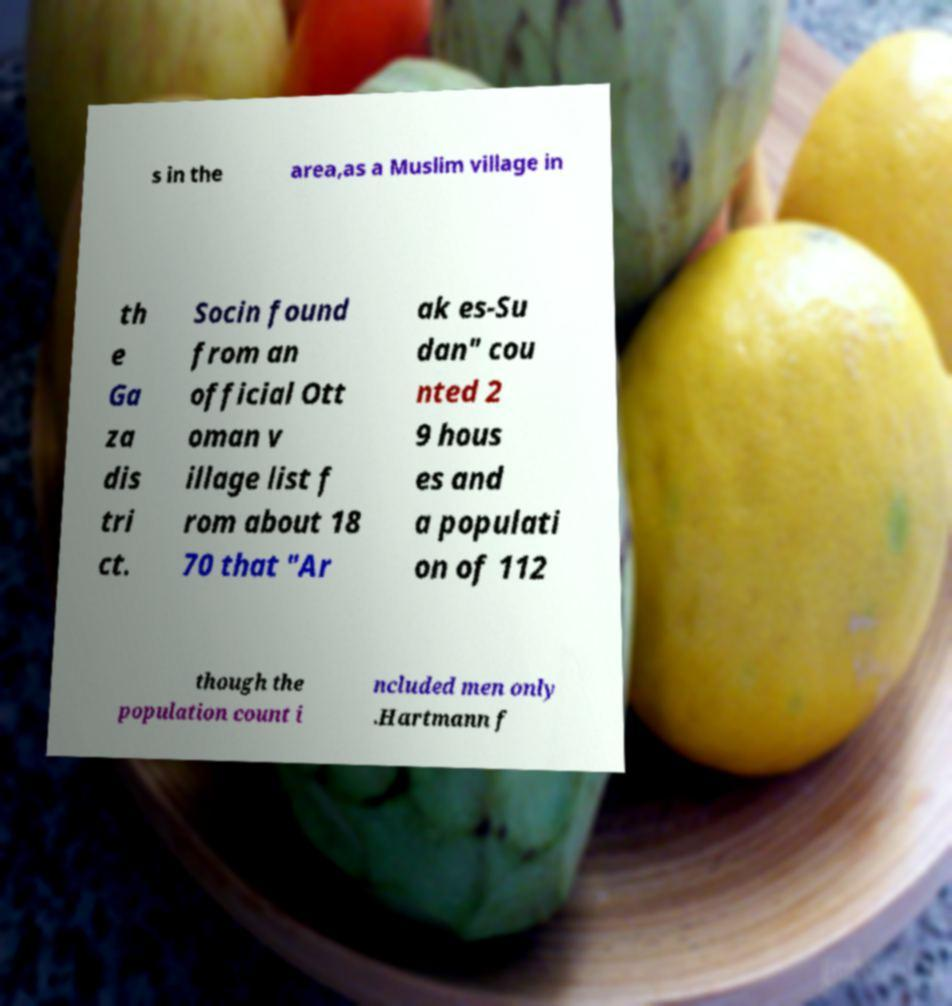What messages or text are displayed in this image? I need them in a readable, typed format. s in the area,as a Muslim village in th e Ga za dis tri ct. Socin found from an official Ott oman v illage list f rom about 18 70 that "Ar ak es-Su dan" cou nted 2 9 hous es and a populati on of 112 though the population count i ncluded men only .Hartmann f 